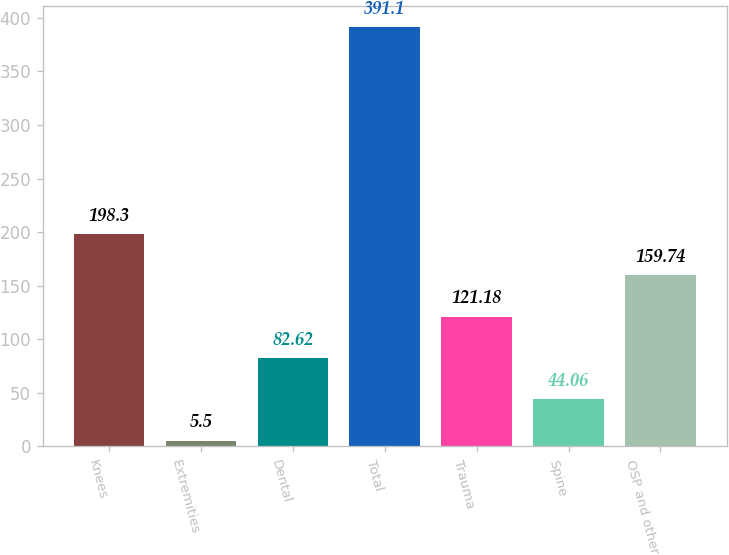<chart> <loc_0><loc_0><loc_500><loc_500><bar_chart><fcel>Knees<fcel>Extremities<fcel>Dental<fcel>Total<fcel>Trauma<fcel>Spine<fcel>OSP and other<nl><fcel>198.3<fcel>5.5<fcel>82.62<fcel>391.1<fcel>121.18<fcel>44.06<fcel>159.74<nl></chart> 